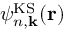<formula> <loc_0><loc_0><loc_500><loc_500>\psi _ { n , { k } } ^ { K S } ( { r } )</formula> 